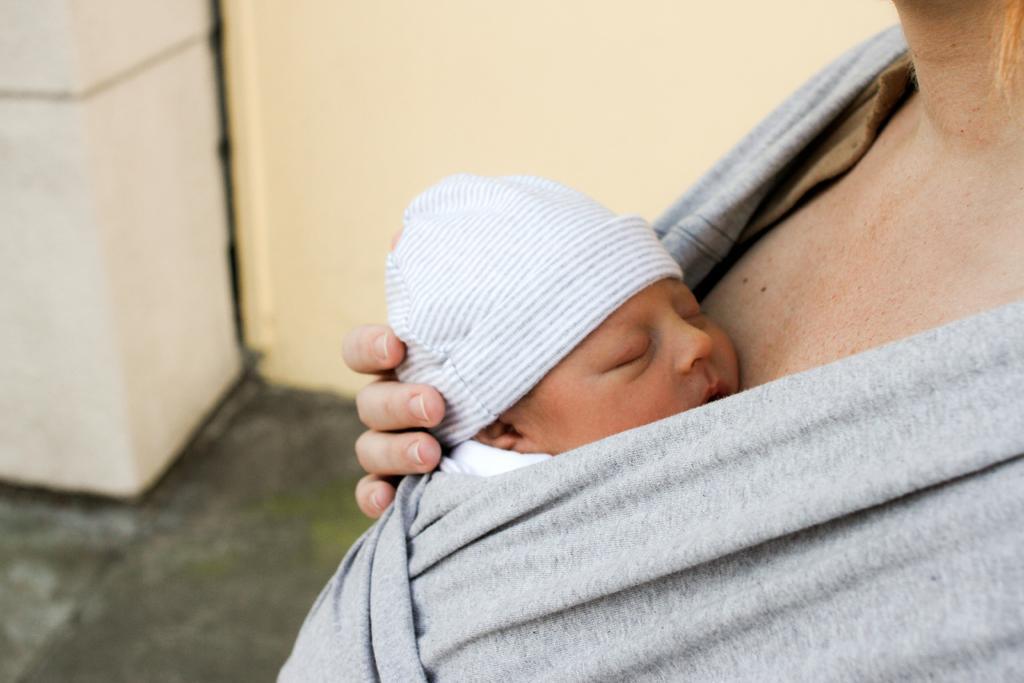Please provide a concise description of this image. In this image, we can see a woman holding a small baby, in the background, we can see the wall, we can see the floor. 